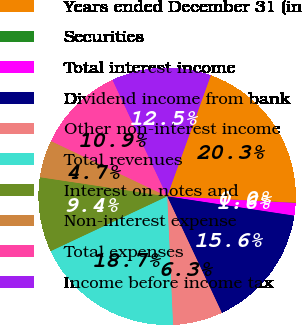Convert chart to OTSL. <chart><loc_0><loc_0><loc_500><loc_500><pie_chart><fcel>Years ended December 31 (in<fcel>Securities<fcel>Total interest income<fcel>Dividend income from bank<fcel>Other non-interest income<fcel>Total revenues<fcel>Interest on notes and<fcel>Non-interest expense<fcel>Total expenses<fcel>Income before income tax<nl><fcel>20.29%<fcel>0.03%<fcel>1.58%<fcel>15.61%<fcel>6.26%<fcel>18.73%<fcel>9.38%<fcel>4.7%<fcel>10.94%<fcel>12.49%<nl></chart> 